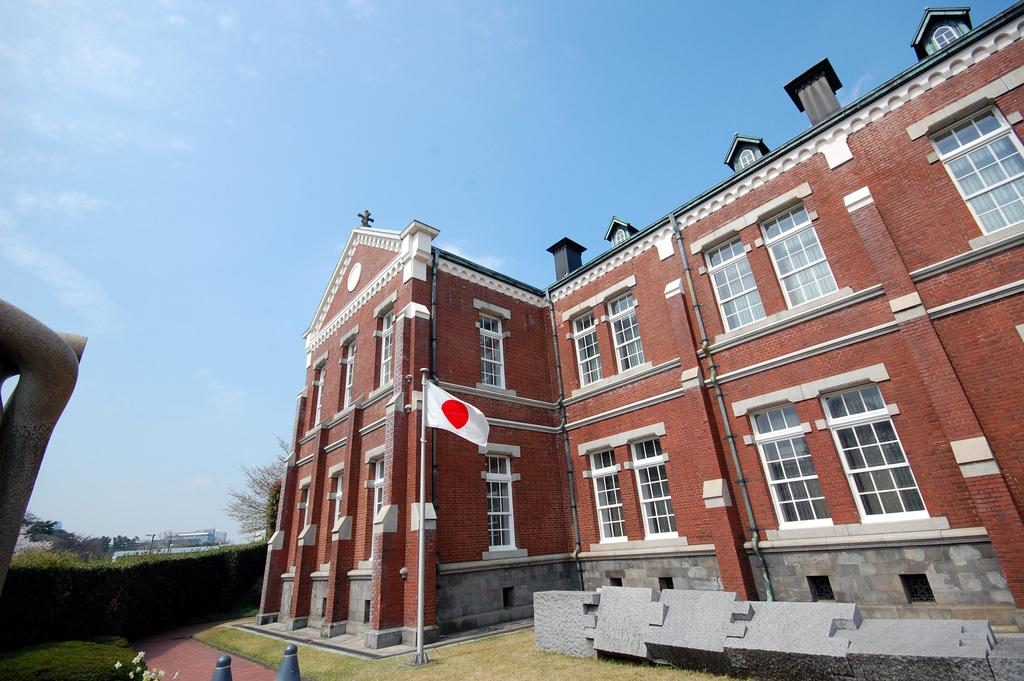What type of structure is visible in the image? There is a building with many windows in the image. What is located in front of the building? There is a flag and rocks in front of the building. What type of vegetation can be seen in the image? There are trees and plants in the image. What additional feature is present in the image? There is a sculpture in the image. How many rings are visible on the trees in the image? There are no rings visible on the trees in the image, as rings are not a feature of trees in real life. 